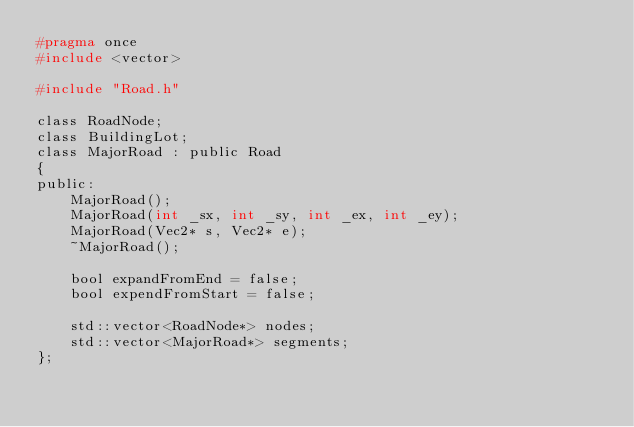Convert code to text. <code><loc_0><loc_0><loc_500><loc_500><_C_>#pragma once
#include <vector>

#include "Road.h"

class RoadNode;
class BuildingLot;
class MajorRoad : public Road
{
public:
	MajorRoad();
	MajorRoad(int _sx, int _sy, int _ex, int _ey);
	MajorRoad(Vec2* s, Vec2* e);
	~MajorRoad();

	bool expandFromEnd = false;
	bool expendFromStart = false;

	std::vector<RoadNode*> nodes;
	std::vector<MajorRoad*> segments;
};</code> 